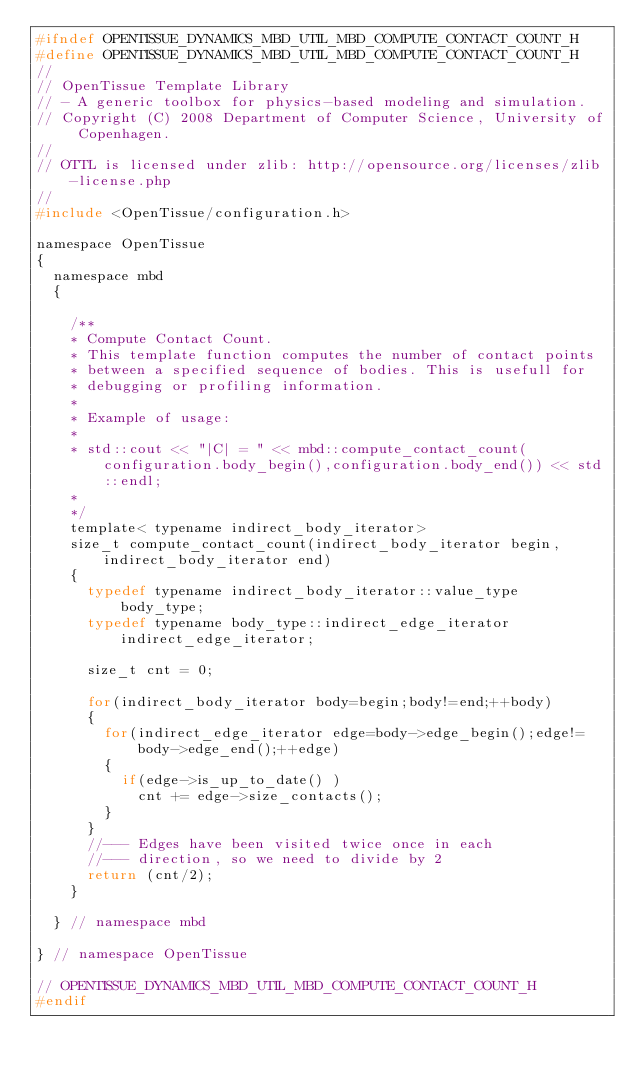Convert code to text. <code><loc_0><loc_0><loc_500><loc_500><_C_>#ifndef OPENTISSUE_DYNAMICS_MBD_UTIL_MBD_COMPUTE_CONTACT_COUNT_H
#define OPENTISSUE_DYNAMICS_MBD_UTIL_MBD_COMPUTE_CONTACT_COUNT_H
//
// OpenTissue Template Library
// - A generic toolbox for physics-based modeling and simulation.
// Copyright (C) 2008 Department of Computer Science, University of Copenhagen.
//
// OTTL is licensed under zlib: http://opensource.org/licenses/zlib-license.php
//
#include <OpenTissue/configuration.h>

namespace OpenTissue
{
  namespace mbd
  {

    /**
    * Compute Contact Count.
    * This template function computes the number of contact points
    * between a specified sequence of bodies. This is usefull for
    * debugging or profiling information.
    *
    * Example of usage:
    *
    * std::cout << "|C| = " << mbd::compute_contact_count(configuration.body_begin(),configuration.body_end()) << std::endl;
    *
    */
    template< typename indirect_body_iterator>
    size_t compute_contact_count(indirect_body_iterator begin, indirect_body_iterator end)
    {
      typedef typename indirect_body_iterator::value_type   body_type;
      typedef typename body_type::indirect_edge_iterator    indirect_edge_iterator;

      size_t cnt = 0;

      for(indirect_body_iterator body=begin;body!=end;++body)
      {
        for(indirect_edge_iterator edge=body->edge_begin();edge!=body->edge_end();++edge)
        {
          if(edge->is_up_to_date() )
            cnt += edge->size_contacts();
        }
      }
      //--- Edges have been visited twice once in each
      //--- direction, so we need to divide by 2
      return (cnt/2);
    }

  } // namespace mbd

} // namespace OpenTissue

// OPENTISSUE_DYNAMICS_MBD_UTIL_MBD_COMPUTE_CONTACT_COUNT_H
#endif
</code> 